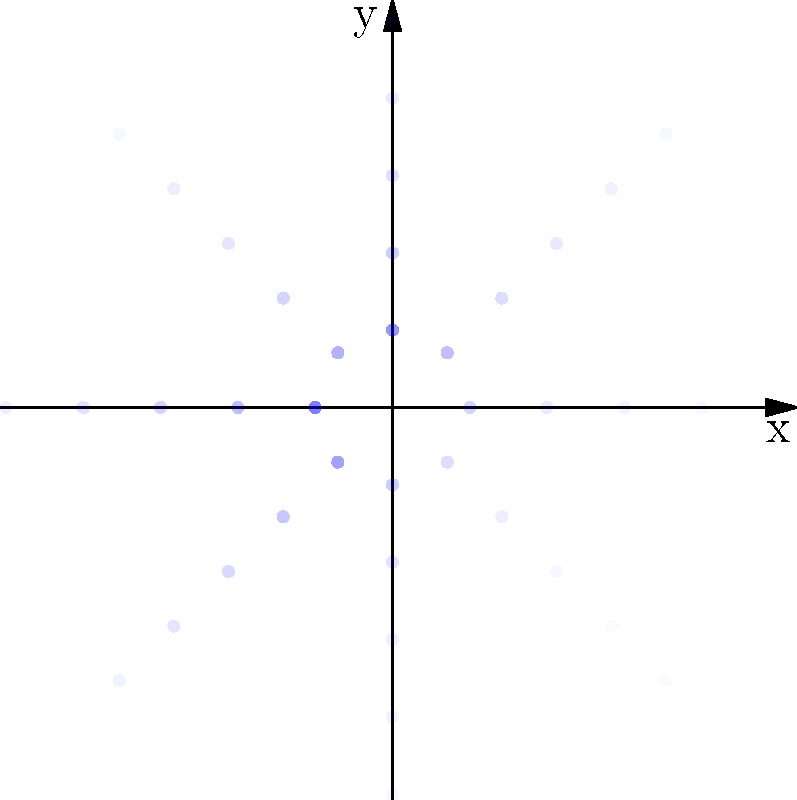In the polar coordinate plot above, pottery fragment distribution is represented by the opacity of blue dots, with darker blue indicating a higher concentration. The concentric circles represent increasing distances from a central excavation point. What pattern of pottery fragment distribution does this plot suggest, and how might it inform our interpretation of the ancient community's activities? To analyze the pattern of pottery fragment distribution:

1. Observe the opacity variation:
   - Darker blue dots indicate higher concentrations of pottery fragments.
   - Lighter blue dots represent lower concentrations.

2. Examine the radial distribution:
   - The innermost circle (r = 1) has the darkest dots overall.
   - Opacity generally decreases as we move outward (r = 2, 3, 4, 5).

3. Analyze the angular distribution:
   - The darkest dots appear in the first quadrant (0 to π/2).
   - There's a secondary concentration in the third quadrant (π to 3π/2).

4. Interpret the findings:
   - Highest concentration near the center suggests intense activity at the excavation point.
   - Gradual decrease outward implies diminishing activity away from the center.
   - Angular variation indicates possible distinct activity areas or structures.

5. Ancient community interpretation:
   - Central area likely represents a primary living or working space.
   - First quadrant concentration might indicate a specialized activity area (e.g., pottery production).
   - Third quadrant concentration could suggest a secondary activity area or structure.
   - Overall pattern implies a centralized community with specific activity zones.

This literal interpretation of the artifact distribution provides insights into the spatial organization and activity patterns of the ancient community.
Answer: Centralized activity with distinct zones radiating outward 